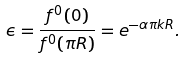<formula> <loc_0><loc_0><loc_500><loc_500>\epsilon = \frac { f ^ { 0 } ( 0 ) } { f ^ { 0 } ( \pi R ) } = e ^ { - \alpha \pi k R } .</formula> 